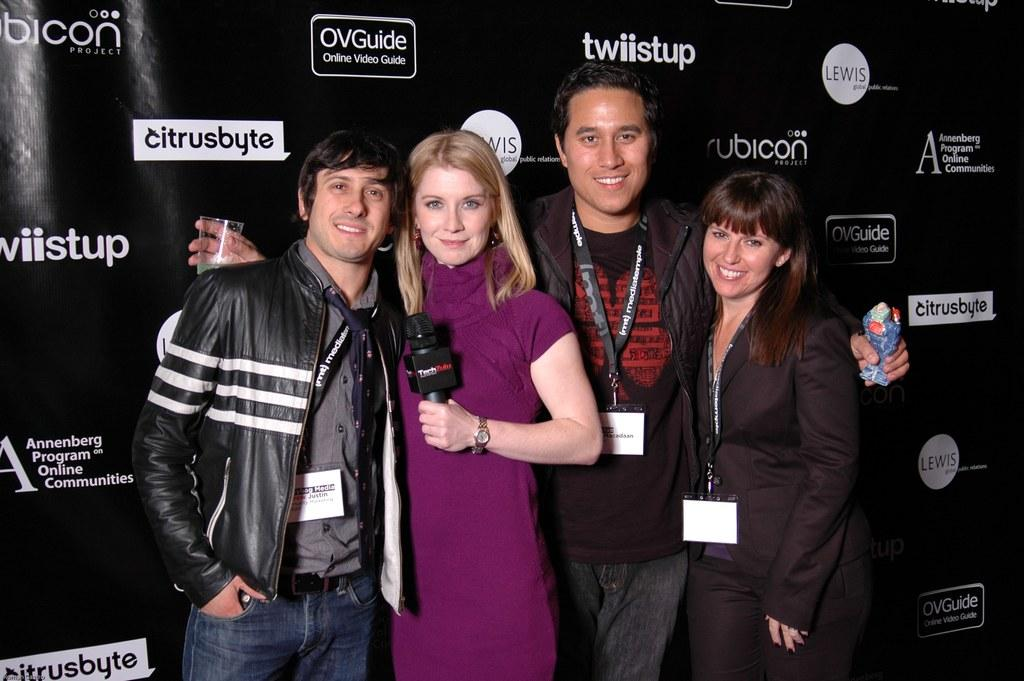<image>
Create a compact narrative representing the image presented. People posing for a photo in front of a black wall which says citrusbyte 